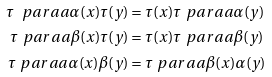<formula> <loc_0><loc_0><loc_500><loc_500>\tau \ p a r a a { \alpha ( x ) } \tau ( y ) & = \tau ( x ) \tau \ p a r a a { \alpha ( y ) } \\ \tau \ p a r a a { \beta ( x ) } \tau ( y ) & = \tau ( x ) \tau \ p a r a a { \beta ( y ) } \\ \tau \ p a r a a { \alpha ( x ) } \beta ( y ) & = \tau \ p a r a a { \beta ( x ) } \alpha ( y )</formula> 